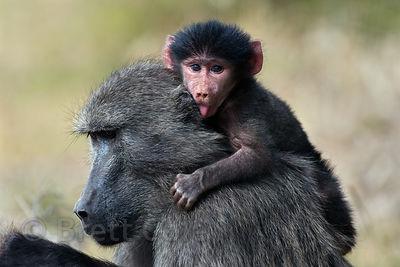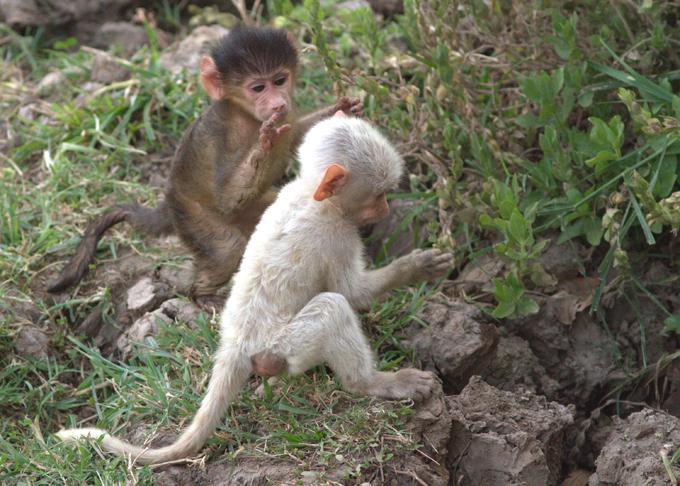The first image is the image on the left, the second image is the image on the right. Analyze the images presented: Is the assertion "There are three monkeys." valid? Answer yes or no. No. The first image is the image on the left, the second image is the image on the right. Analyze the images presented: Is the assertion "In the image on the left, a mother carries her baby." valid? Answer yes or no. Yes. 